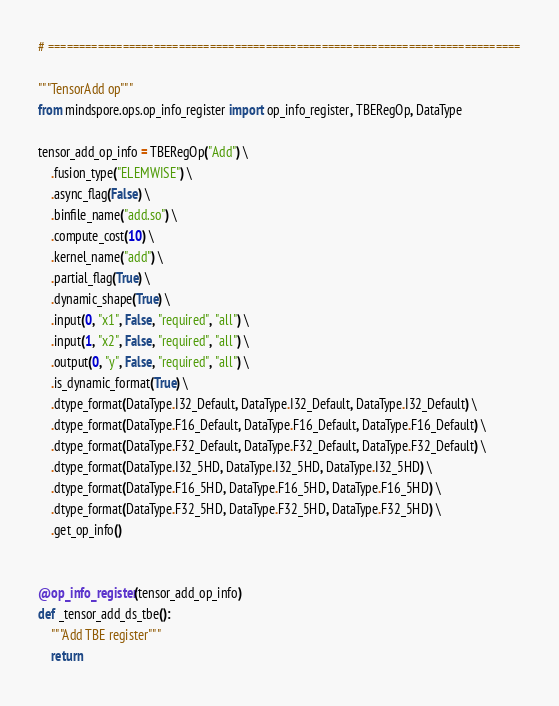Convert code to text. <code><loc_0><loc_0><loc_500><loc_500><_Python_># ============================================================================

"""TensorAdd op"""
from mindspore.ops.op_info_register import op_info_register, TBERegOp, DataType

tensor_add_op_info = TBERegOp("Add") \
    .fusion_type("ELEMWISE") \
    .async_flag(False) \
    .binfile_name("add.so") \
    .compute_cost(10) \
    .kernel_name("add") \
    .partial_flag(True) \
    .dynamic_shape(True) \
    .input(0, "x1", False, "required", "all") \
    .input(1, "x2", False, "required", "all") \
    .output(0, "y", False, "required", "all") \
    .is_dynamic_format(True) \
    .dtype_format(DataType.I32_Default, DataType.I32_Default, DataType.I32_Default) \
    .dtype_format(DataType.F16_Default, DataType.F16_Default, DataType.F16_Default) \
    .dtype_format(DataType.F32_Default, DataType.F32_Default, DataType.F32_Default) \
    .dtype_format(DataType.I32_5HD, DataType.I32_5HD, DataType.I32_5HD) \
    .dtype_format(DataType.F16_5HD, DataType.F16_5HD, DataType.F16_5HD) \
    .dtype_format(DataType.F32_5HD, DataType.F32_5HD, DataType.F32_5HD) \
    .get_op_info()


@op_info_register(tensor_add_op_info)
def _tensor_add_ds_tbe():
    """Add TBE register"""
    return
</code> 